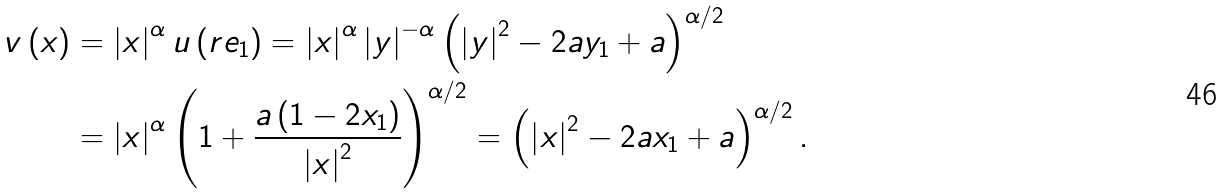Convert formula to latex. <formula><loc_0><loc_0><loc_500><loc_500>v \left ( x \right ) & = \left | x \right | ^ { \alpha } u \left ( r e _ { 1 } \right ) = \left | x \right | ^ { \alpha } \left | y \right | ^ { - \alpha } \left ( \left | y \right | ^ { 2 } - 2 a y _ { 1 } + a \right ) ^ { \alpha / 2 } \\ & = \left | x \right | ^ { \alpha } \left ( 1 + \frac { a \left ( 1 - 2 x _ { 1 } \right ) } { \left | x \right | ^ { 2 } } \right ) ^ { \alpha / 2 } = \left ( \left | x \right | ^ { 2 } - 2 a x _ { 1 } + a \right ) ^ { \alpha / 2 } .</formula> 